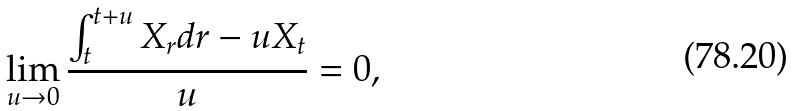Convert formula to latex. <formula><loc_0><loc_0><loc_500><loc_500>\lim _ { u \rightarrow 0 } \frac { \int _ { t } ^ { t + u } X _ { r } d r - u X _ { t } } { u } = 0 ,</formula> 